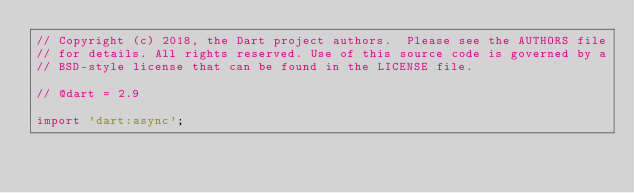<code> <loc_0><loc_0><loc_500><loc_500><_Dart_>// Copyright (c) 2018, the Dart project authors.  Please see the AUTHORS file
// for details. All rights reserved. Use of this source code is governed by a
// BSD-style license that can be found in the LICENSE file.

// @dart = 2.9

import 'dart:async';</code> 